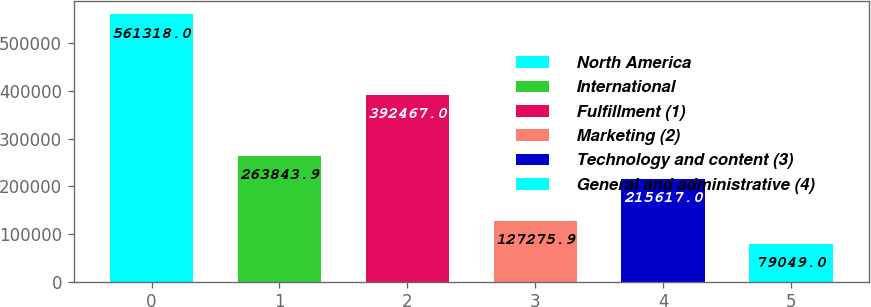<chart> <loc_0><loc_0><loc_500><loc_500><bar_chart><fcel>North America<fcel>International<fcel>Fulfillment (1)<fcel>Marketing (2)<fcel>Technology and content (3)<fcel>General and administrative (4)<nl><fcel>561318<fcel>263844<fcel>392467<fcel>127276<fcel>215617<fcel>79049<nl></chart> 